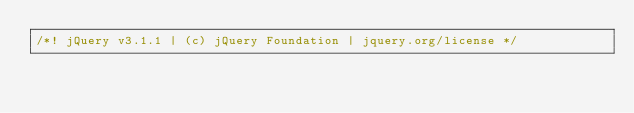Convert code to text. <code><loc_0><loc_0><loc_500><loc_500><_JavaScript_>/*! jQuery v3.1.1 | (c) jQuery Foundation | jquery.org/license */</code> 